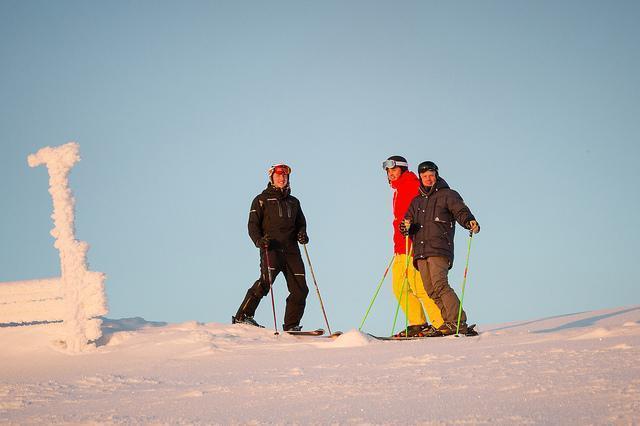How many people are standing?
Give a very brief answer. 3. How many people are visible?
Give a very brief answer. 3. 